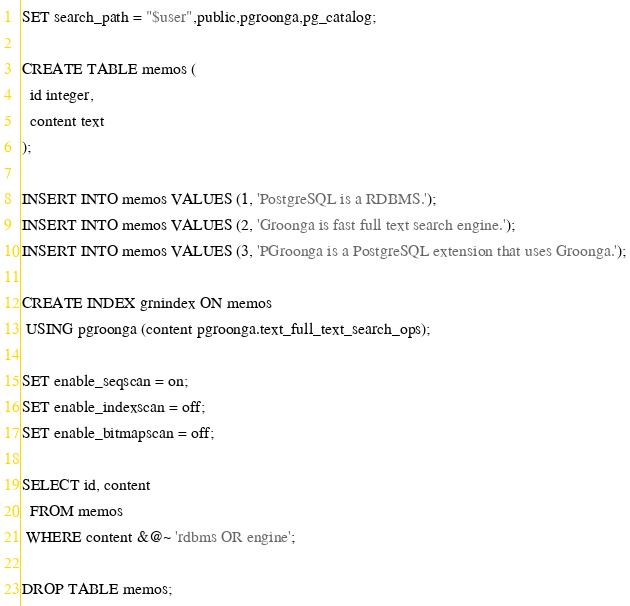<code> <loc_0><loc_0><loc_500><loc_500><_SQL_>SET search_path = "$user",public,pgroonga,pg_catalog;

CREATE TABLE memos (
  id integer,
  content text
);

INSERT INTO memos VALUES (1, 'PostgreSQL is a RDBMS.');
INSERT INTO memos VALUES (2, 'Groonga is fast full text search engine.');
INSERT INTO memos VALUES (3, 'PGroonga is a PostgreSQL extension that uses Groonga.');

CREATE INDEX grnindex ON memos
 USING pgroonga (content pgroonga.text_full_text_search_ops);

SET enable_seqscan = on;
SET enable_indexscan = off;
SET enable_bitmapscan = off;

SELECT id, content
  FROM memos
 WHERE content &@~ 'rdbms OR engine';

DROP TABLE memos;
</code> 